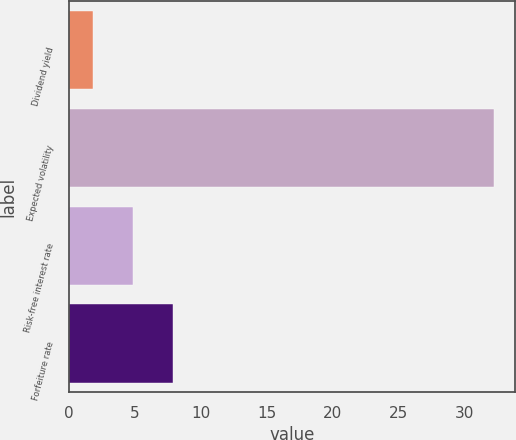Convert chart. <chart><loc_0><loc_0><loc_500><loc_500><bar_chart><fcel>Dividend yield<fcel>Expected volatility<fcel>Risk-free interest rate<fcel>Forfeiture rate<nl><fcel>1.8<fcel>32.2<fcel>4.84<fcel>7.88<nl></chart> 